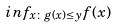Convert formula to latex. <formula><loc_0><loc_0><loc_500><loc_500>i n f _ { x \colon g ( x ) \leq y } f ( x )</formula> 